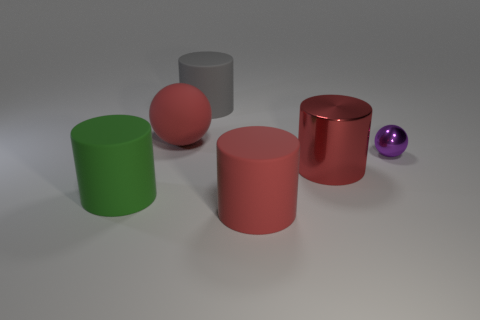Add 2 large green metal cubes. How many objects exist? 8 Subtract all balls. How many objects are left? 4 Add 1 red shiny cylinders. How many red shiny cylinders are left? 2 Add 4 large shiny spheres. How many large shiny spheres exist? 4 Subtract 0 purple cylinders. How many objects are left? 6 Subtract all metallic spheres. Subtract all large green rubber things. How many objects are left? 4 